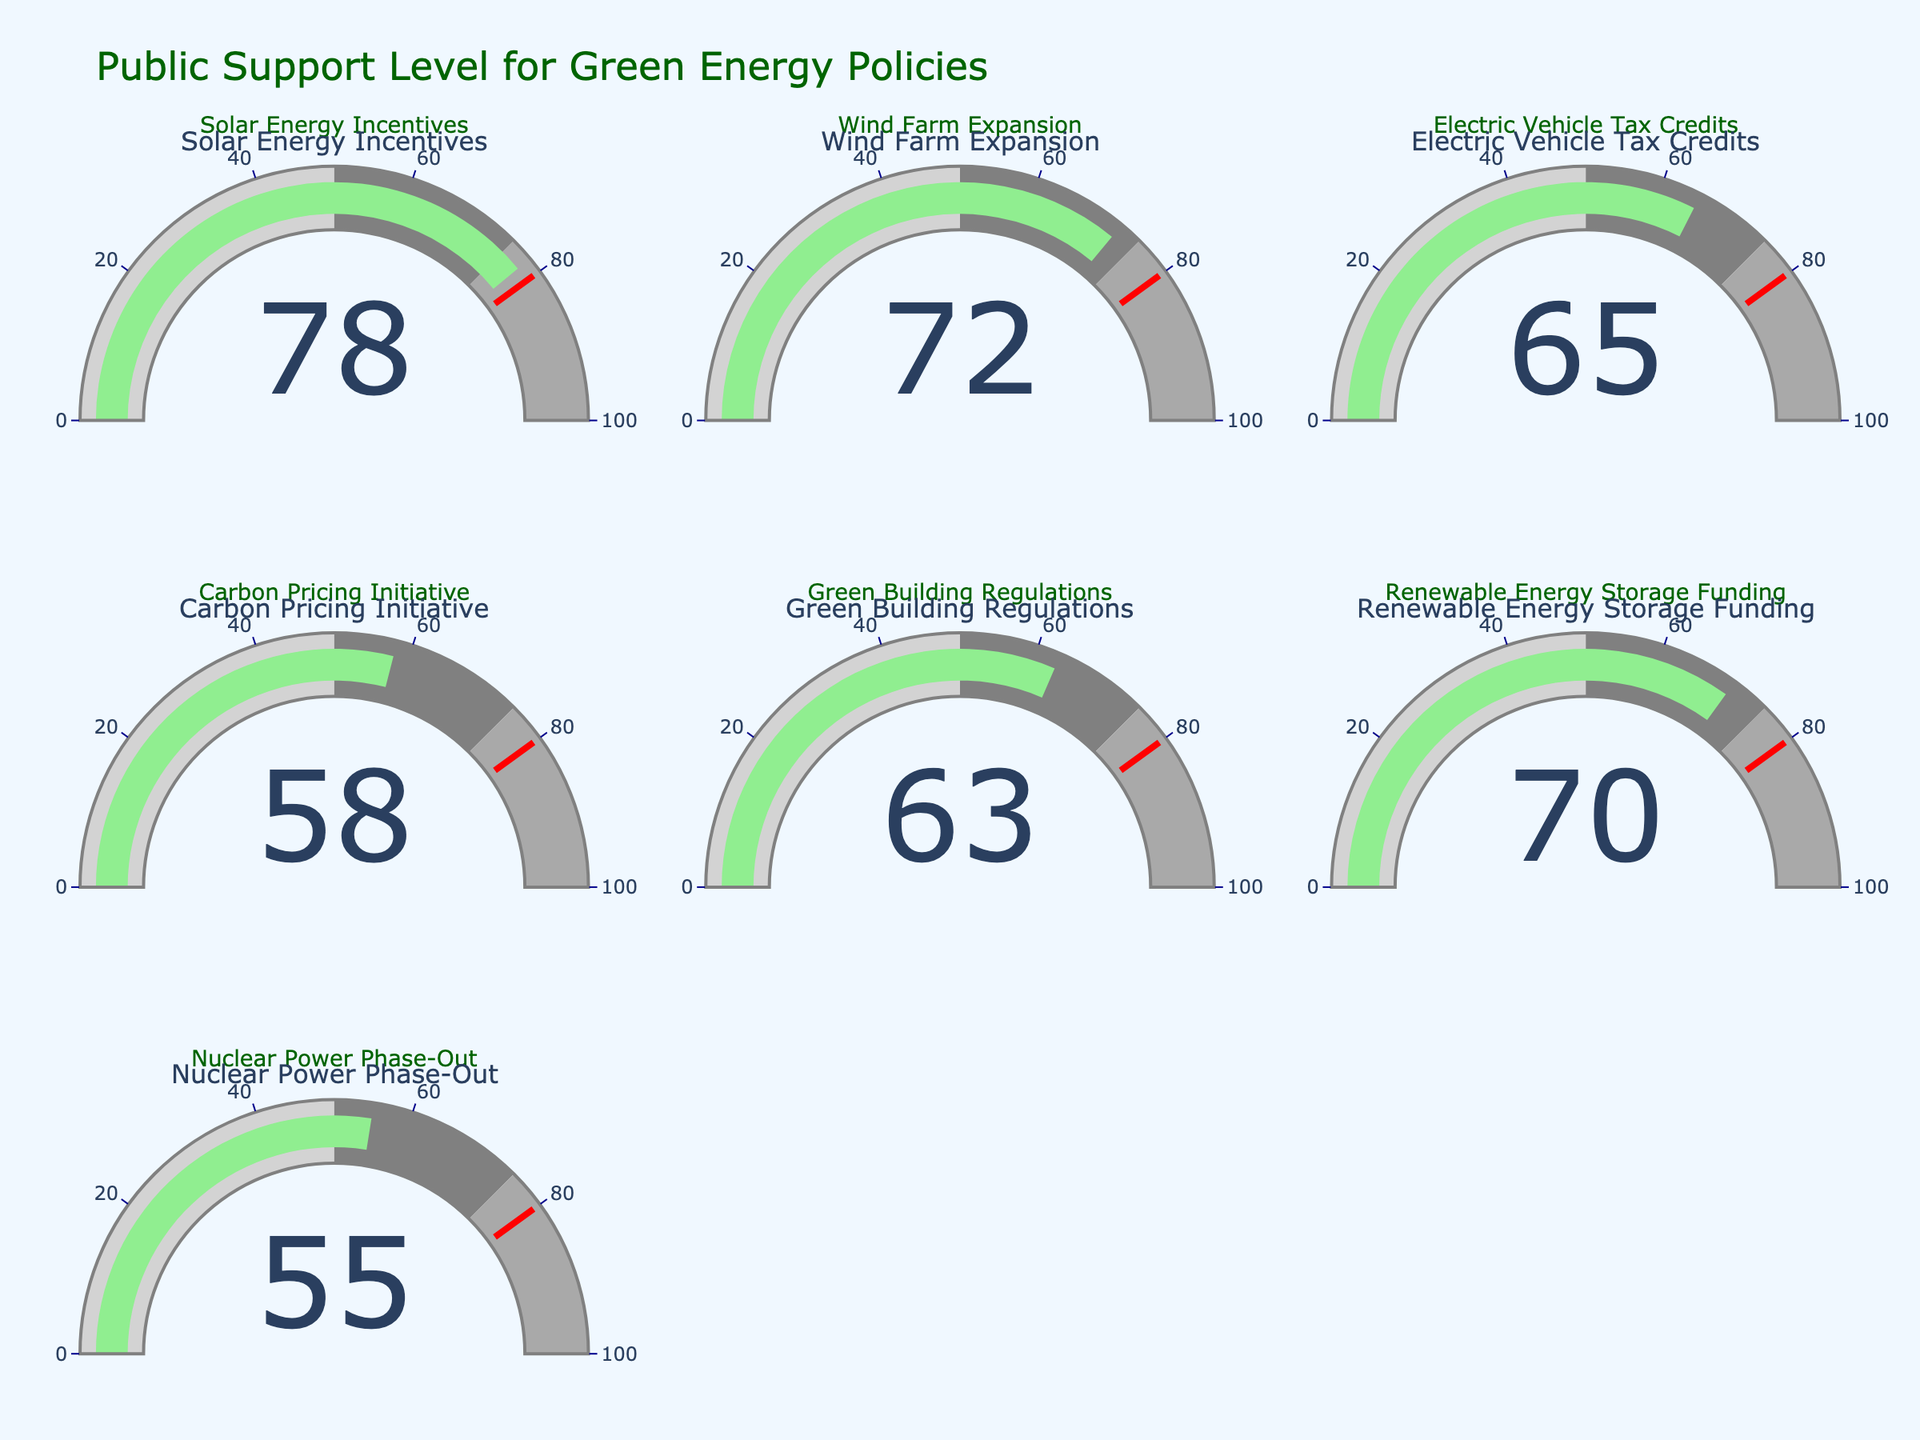What is the value on the gauge for "Solar Energy Incentives"? The gauge shows 78 for the "Solar Energy Incentives" policy.
Answer: 78 Which policy has the lowest public support level? Checking all the gauges, "Nuclear Power Phase-Out" has the lowest value at 55.
Answer: Nuclear Power Phase-Out What is the average support level for all the policies combined? Adding all the support levels: (78 + 72 + 65 + 58 + 63 + 70 + 55) = 461. Dividing by the number of policies (7), we get 461 / 7 ≈ 65.86.
Answer: 65.86 How many policies have a support level greater than 70? The policies with support levels greater than 70 are "Solar Energy Incentives" (78) and "Wind Farm Expansion" (72).
Answer: 2 Which policy falls exactly in the middle range (50-75) of the gauge scale? The policies that fall in the range 50 to 75 are "Wind Farm Expansion" (72), "Electric Vehicle Tax Credits" (65), "Green Building Regulations" (63), and "Renewable Energy Storage Funding" (70).
Answer: Wind Farm Expansion, Electric Vehicle Tax Credits, Green Building Regulations, Renewable Energy Storage Funding Is the support level for "Carbon Pricing Initiative" above or below the median support level of all policies? Ordering the support levels (55, 58, 63, 65, 70, 72, 78), the median is 65. The "Carbon Pricing Initiative" has a support level of 58, which is below 65.
Answer: Below Which policy is closest to the threshold value of 80? The support level closest to 80 is "Solar Energy Incentives" with a value of 78.
Answer: Solar Energy Incentives What is the difference in support levels between "Electric Vehicle Tax Credits" and "Nuclear Power Phase-Out"? The support level for "Electric Vehicle Tax Credits" is 65, and for "Nuclear Power Phase-Out" it is 55. The difference is 65 - 55 = 10.
Answer: 10 